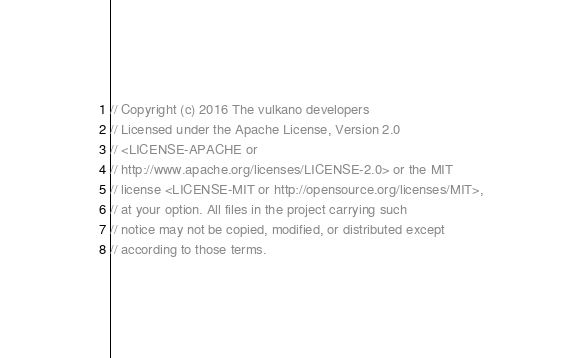<code> <loc_0><loc_0><loc_500><loc_500><_Rust_>// Copyright (c) 2016 The vulkano developers
// Licensed under the Apache License, Version 2.0
// <LICENSE-APACHE or
// http://www.apache.org/licenses/LICENSE-2.0> or the MIT
// license <LICENSE-MIT or http://opensource.org/licenses/MIT>,
// at your option. All files in the project carrying such
// notice may not be copied, modified, or distributed except
// according to those terms.
</code> 